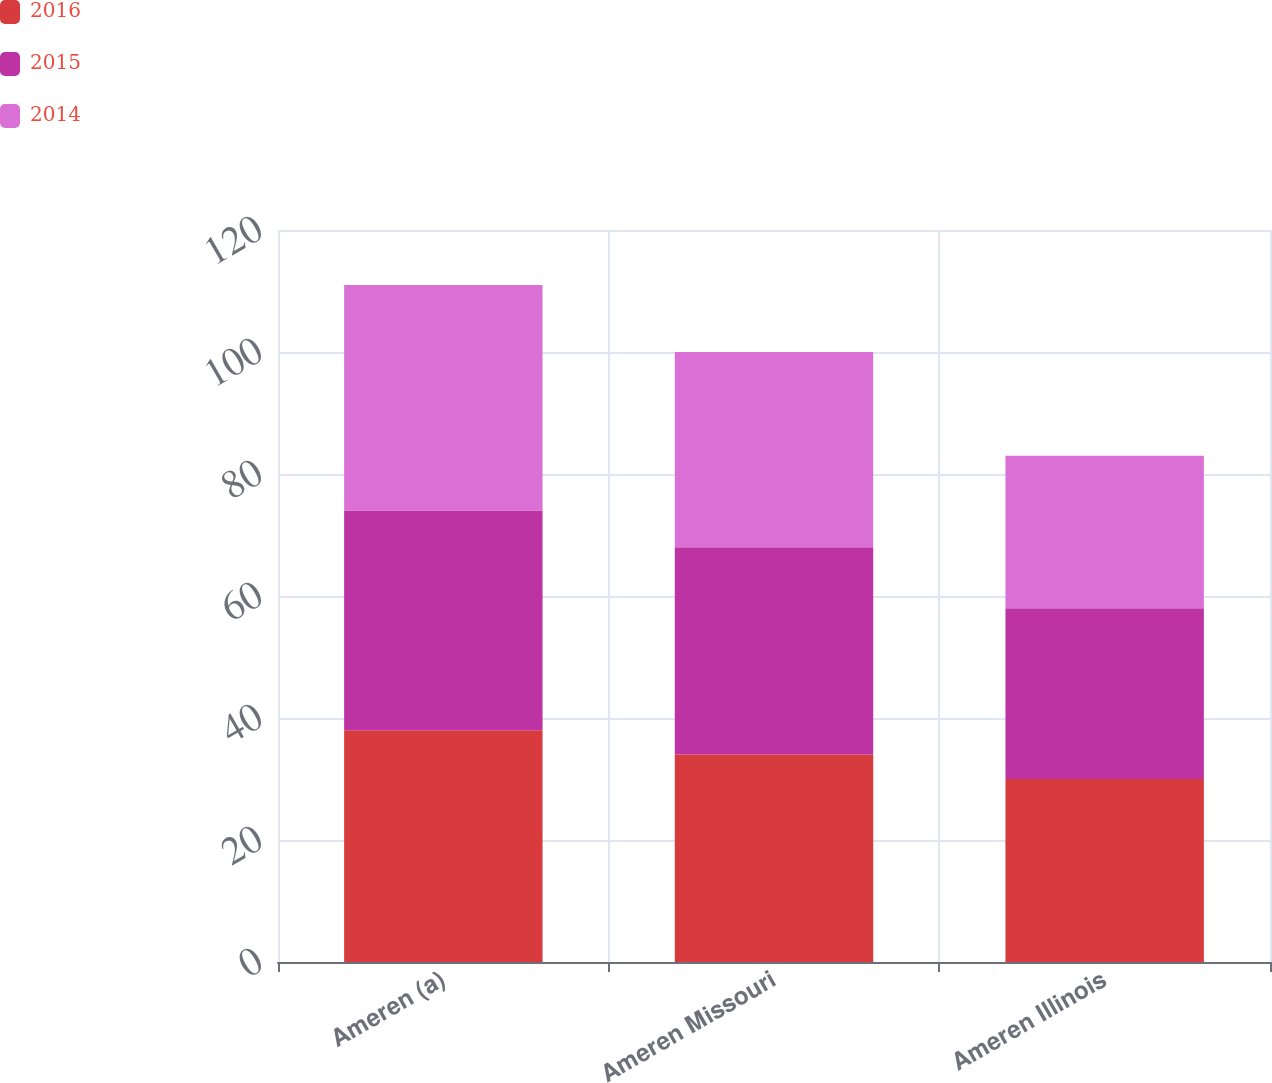Convert chart to OTSL. <chart><loc_0><loc_0><loc_500><loc_500><stacked_bar_chart><ecel><fcel>Ameren (a)<fcel>Ameren Missouri<fcel>Ameren Illinois<nl><fcel>2016<fcel>38<fcel>34<fcel>30<nl><fcel>2015<fcel>36<fcel>34<fcel>28<nl><fcel>2014<fcel>37<fcel>32<fcel>25<nl></chart> 